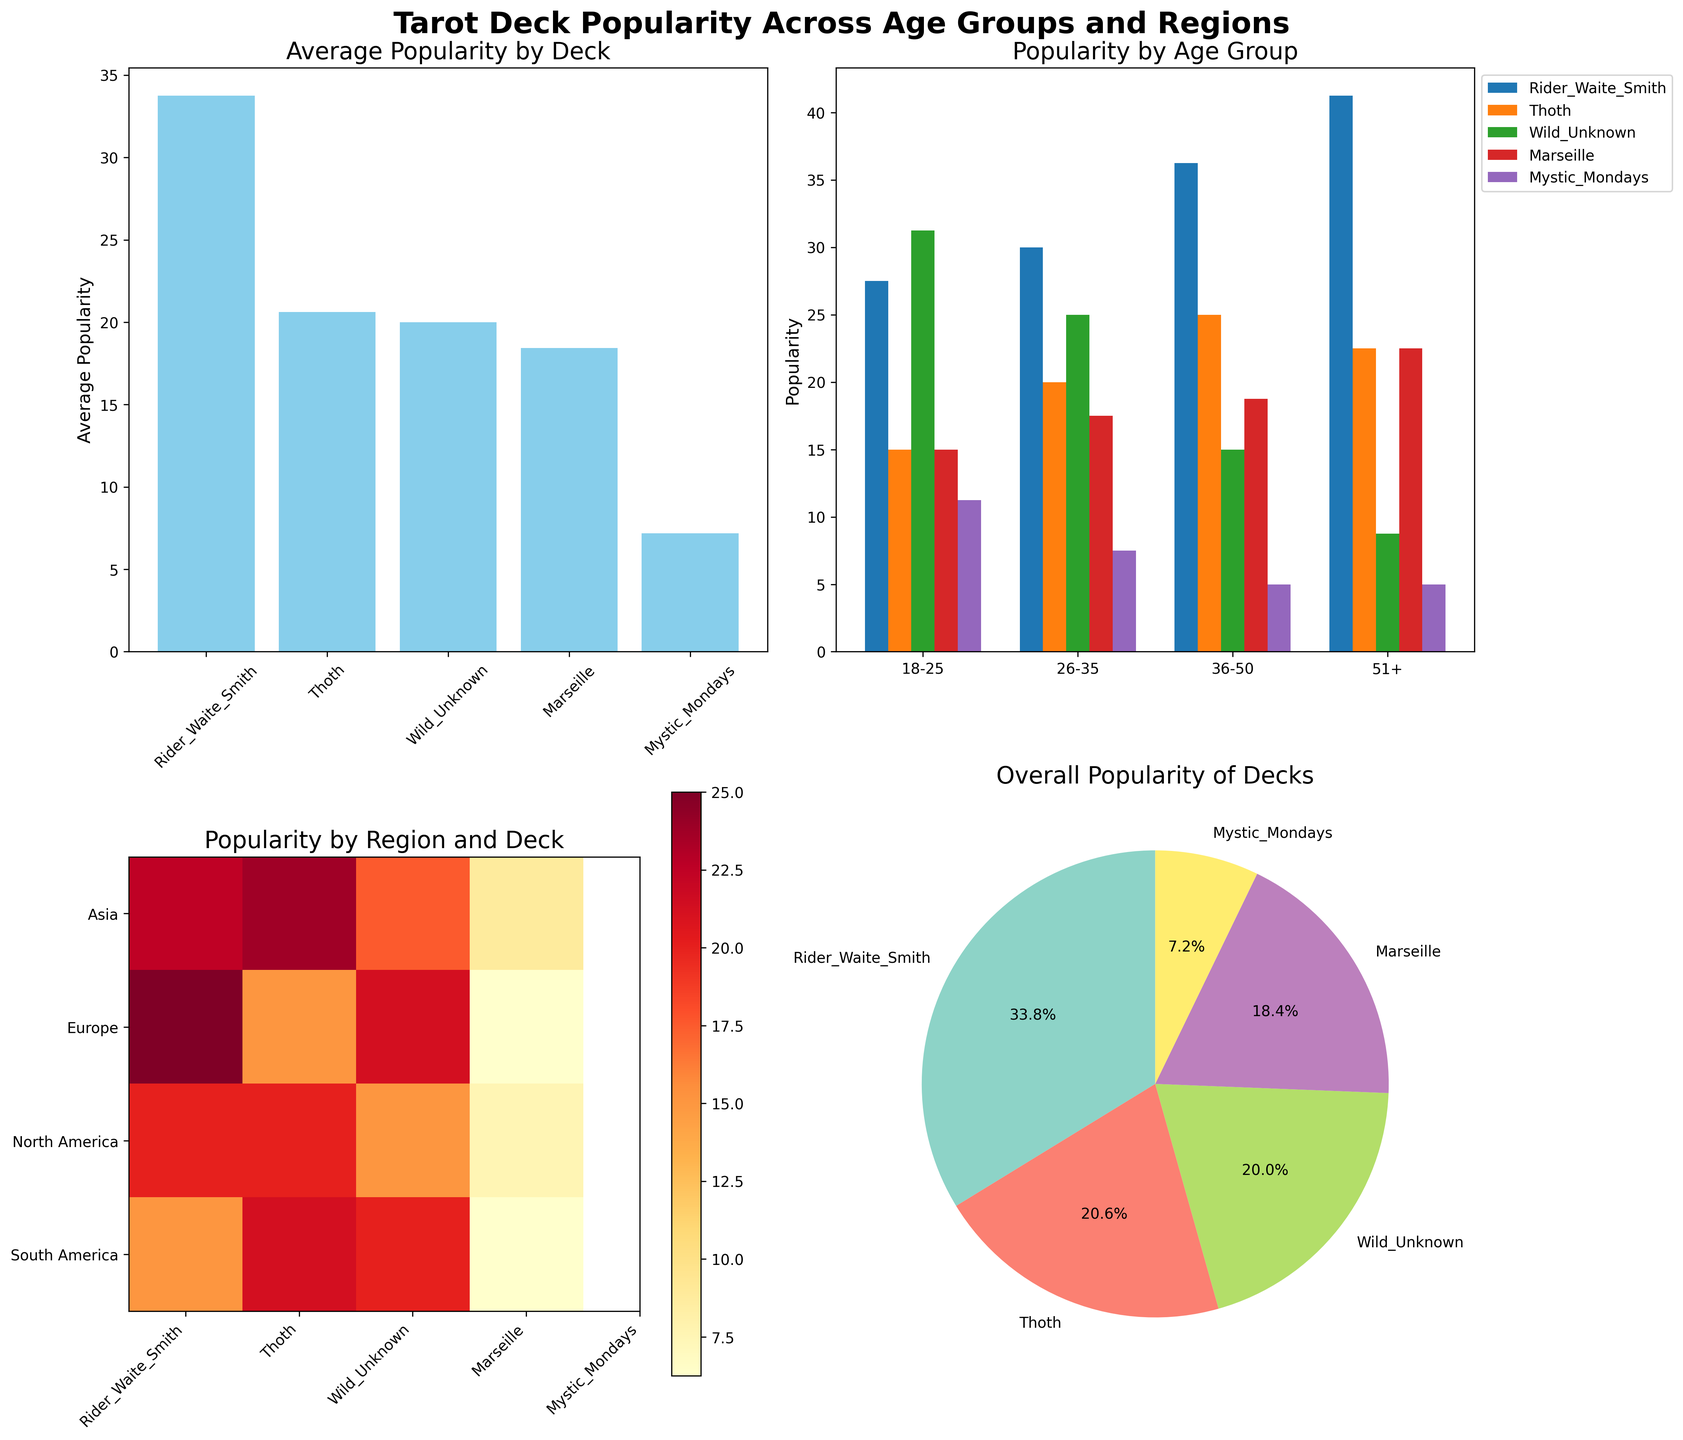What is the most popular tarot deck on average? The bar chart titled "Average Popularity by Deck" shows the average popularity of each tarot deck. The deck with the highest bar represents the most popular one on average.
Answer: Rider Waite Smith How does the Rider Waite Smith deck's popularity change across age groups? Refer to the stacked bar chart titled "Popularity by Age Group". Observe the blue bars corresponding to Rider Waite Smith for each age group to see the changes.
Answer: It increases with age Which region prefers the Thoth deck the most? Look at the heatmap titled "Popularity by Region and Deck". Identify the row with the highest intensity of color for the Thoth deck column.
Answer: Asia Which age group shows the least preference for the Wild Unknown deck? In the stacked bar chart "Popularity by Age Group", find the age group with the smallest red bar representing the Wild Unknown deck.
Answer: Age 36-50 What percentage of the overall tarot deck popularity does the Mystic Mondays deck hold? The pie chart titled "Overall Popularity of Decks" shows this data. Look at the label on the Mystic Mondays segment.
Answer: 6.7% Between Europe and South America, which region shows higher popularity for the Marseille deck? Examine the heatmap "Popularity by Region and Deck". Compare the color intensity for the Marseille deck between Europe and South America rows.
Answer: South America What is the combined average popularity of the Marseille and Mystic Mondays decks across all regions? From the bar chart "Average Popularity by Deck", add the average values of Marseille and Mystic Mondays, and then divide by 2 to find the combined average.
Answer: 10 Which age group's preference for tarot decks is most evenly distributed? In the stacked bar chart "Popularity by Age Group", check for the age group where all bars are nearly the same height, indicating an even distribution.
Answer: Age 26-35 Which deck is most preferred by people aged 51+ in any region? In the stacked bar chart "Popularity by Age Group", look at the tallest bar for the age group 51+.
Answer: Rider Waite Smith 